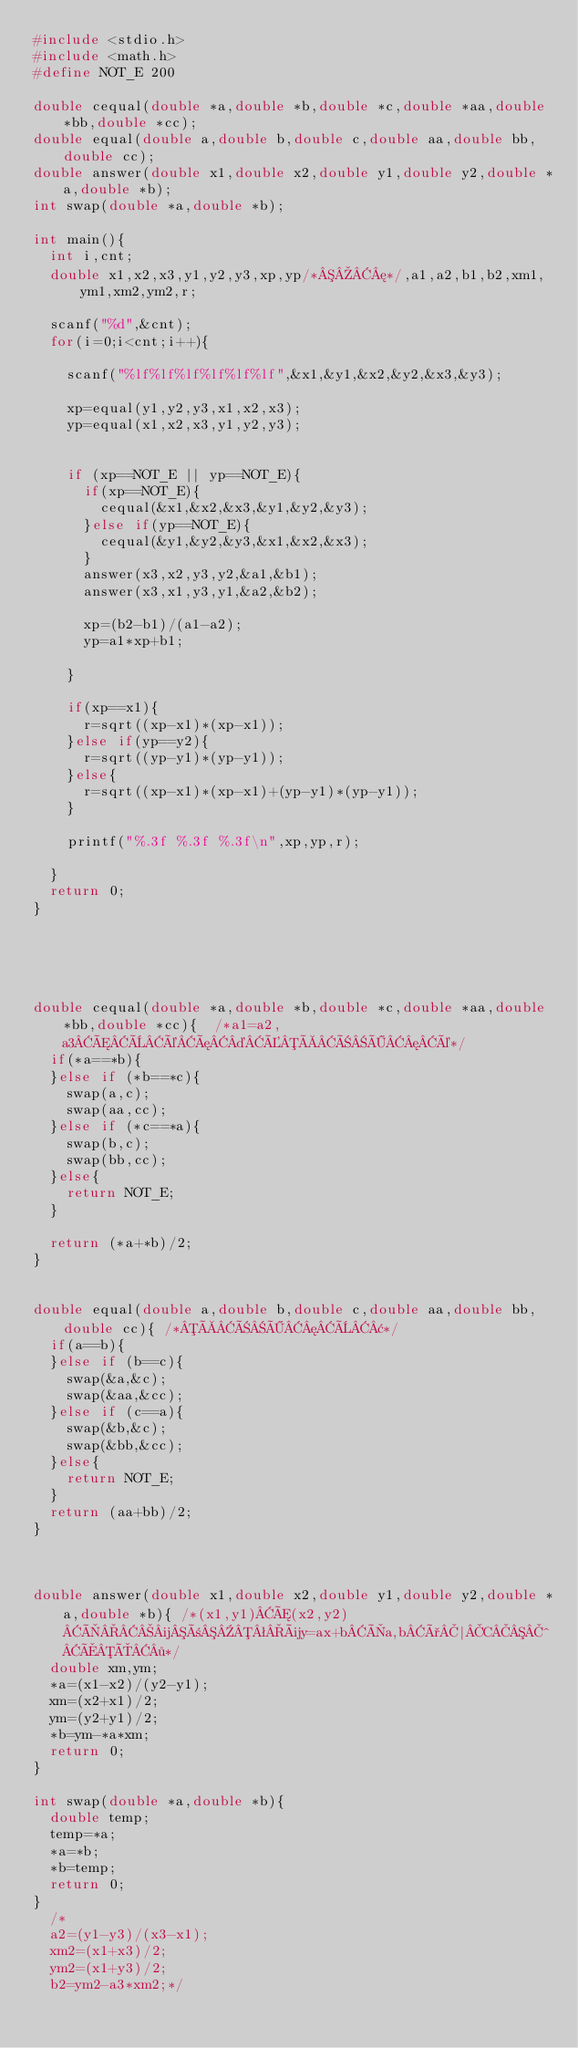Convert code to text. <code><loc_0><loc_0><loc_500><loc_500><_C_>#include <stdio.h>
#include <math.h>
#define NOT_E 200

double cequal(double *a,double *b,double *c,double *aa,double *bb,double *cc);
double equal(double a,double b,double c,double aa,double bb,double cc);
double answer(double x1,double x2,double y1,double y2,double *a,double *b);
int swap(double *a,double *b);

int main(){
	int i,cnt;
	double x1,x2,x3,y1,y2,y3,xp,yp/*¦*/,a1,a2,b1,b2,xm1,ym1,xm2,ym2,r;
	
	scanf("%d",&cnt);
	for(i=0;i<cnt;i++){
		
		scanf("%lf%lf%lf%lf%lf%lf",&x1,&y1,&x2,&y2,&x3,&y3);
		
		xp=equal(y1,y2,y3,x1,x2,x3);
		yp=equal(x1,x2,x3,y1,y2,y3);
		
		
		if (xp==NOT_E || yp==NOT_E){
			if(xp==NOT_E){
				cequal(&x1,&x2,&x3,&y1,&y2,&y3);
			}else if(yp==NOT_E){
				cequal(&y1,&y2,&y3,&x1,&x2,&x3);
			}
			answer(x3,x2,y3,y2,&a1,&b1);
			answer(x3,x1,y3,y1,&a2,&b2);
			
			xp=(b2-b1)/(a1-a2);
			yp=a1*xp+b1;
			
		}
		
		if(xp==x1){
			r=sqrt((xp-x1)*(xp-x1));
		}else if(yp==y2){
			r=sqrt((yp-y1)*(yp-y1));
		}else{
			r=sqrt((xp-x1)*(xp-x1)+(yp-y1)*(yp-y1));
		}
		
		printf("%.3f %.3f %.3f\n",xp,yp,r);

	}
	return 0;
}
			
			
			
			

double cequal(double *a,double *b,double *c,double *aa,double *bb,double *cc){	/*a1=a2,a3ÆÈéæ¤ÉÀÑÖ¦é*/
	if(*a==*b){
	}else if (*b==*c){
		swap(a,c);
		swap(aa,cc);
	}else if (*c==*a){
		swap(b,c);
		swap(bb,cc);
	}else{
		return NOT_E;
	}
	
	return (*a+*b)/2;
}


double equal(double a,double b,double c,double aa,double bb,double cc){	/*ÀÑÖ¦È¢*/
	if(a==b){
	}else if (b==c){
		swap(&a,&c);
		swap(&aa,&cc);
	}else if (c==a){
		swap(&b,&c);
		swap(&bb,&cc);
	}else{
		return NOT_E;
	}
	return (aa+bb)/2;
}



double answer(double x1,double x2,double y1,double y2,double *a,double *b){	/*(x1,y1)Æ(x2,y2)Ì¼ñªüy=ax+bÌa,bð|C^ÅÔ·*/
	double xm,ym;
	*a=(x1-x2)/(y2-y1);
	xm=(x2+x1)/2;
	ym=(y2+y1)/2;
	*b=ym-*a*xm;
	return 0;
}

int swap(double *a,double *b){
	double temp;
	temp=*a;
	*a=*b;
	*b=temp;
	return 0;
}
	/*
	a2=(y1-y3)/(x3-x1);
	xm2=(x1+x3)/2;
	ym2=(x1+y3)/2;
	b2=ym2-a3*xm2;*/
	</code> 